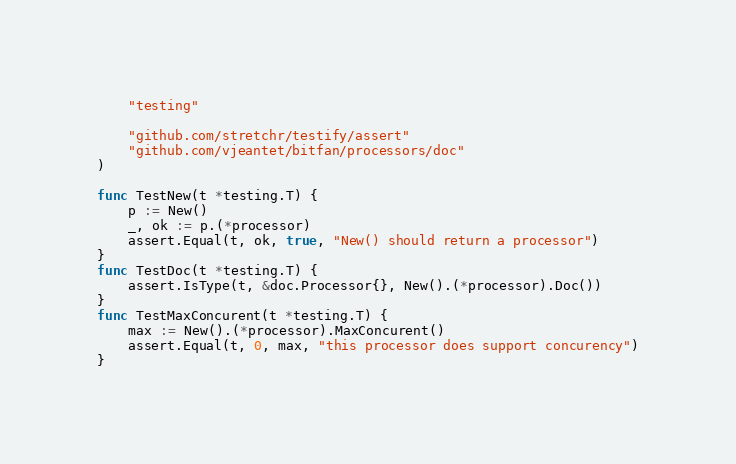<code> <loc_0><loc_0><loc_500><loc_500><_Go_>	"testing"

	"github.com/stretchr/testify/assert"
	"github.com/vjeantet/bitfan/processors/doc"
)

func TestNew(t *testing.T) {
	p := New()
	_, ok := p.(*processor)
	assert.Equal(t, ok, true, "New() should return a processor")
}
func TestDoc(t *testing.T) {
	assert.IsType(t, &doc.Processor{}, New().(*processor).Doc())
}
func TestMaxConcurent(t *testing.T) {
	max := New().(*processor).MaxConcurent()
	assert.Equal(t, 0, max, "this processor does support concurency")
}
</code> 